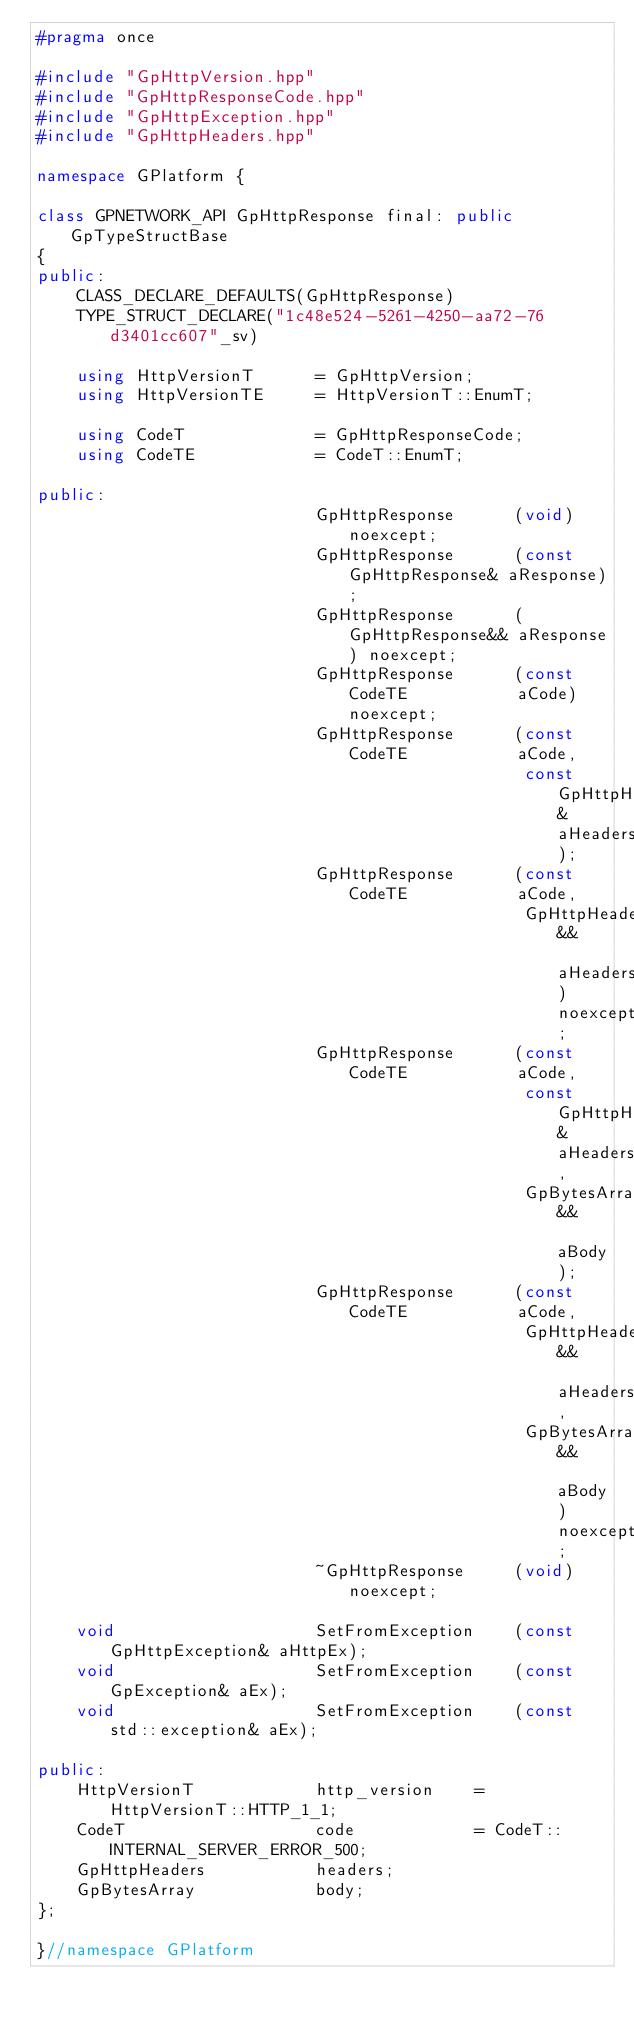Convert code to text. <code><loc_0><loc_0><loc_500><loc_500><_C++_>#pragma once

#include "GpHttpVersion.hpp"
#include "GpHttpResponseCode.hpp"
#include "GpHttpException.hpp"
#include "GpHttpHeaders.hpp"

namespace GPlatform {

class GPNETWORK_API GpHttpResponse final: public GpTypeStructBase
{
public:
    CLASS_DECLARE_DEFAULTS(GpHttpResponse)
    TYPE_STRUCT_DECLARE("1c48e524-5261-4250-aa72-76d3401cc607"_sv)

    using HttpVersionT      = GpHttpVersion;
    using HttpVersionTE     = HttpVersionT::EnumT;

    using CodeT             = GpHttpResponseCode;
    using CodeTE            = CodeT::EnumT;

public:
                            GpHttpResponse      (void) noexcept;
                            GpHttpResponse      (const GpHttpResponse& aResponse);
                            GpHttpResponse      (GpHttpResponse&& aResponse) noexcept;
                            GpHttpResponse      (const CodeTE           aCode) noexcept;
                            GpHttpResponse      (const CodeTE           aCode,
                                                 const GpHttpHeaders&   aHeaders);
                            GpHttpResponse      (const CodeTE           aCode,
                                                 GpHttpHeaders&&        aHeaders) noexcept;
                            GpHttpResponse      (const CodeTE           aCode,
                                                 const GpHttpHeaders&   aHeaders,
                                                 GpBytesArray&&         aBody);
                            GpHttpResponse      (const CodeTE           aCode,
                                                 GpHttpHeaders&&        aHeaders,
                                                 GpBytesArray&&         aBody) noexcept;
                            ~GpHttpResponse     (void) noexcept;

    void                    SetFromException    (const GpHttpException& aHttpEx);
    void                    SetFromException    (const GpException& aEx);
    void                    SetFromException    (const std::exception& aEx);

public:
    HttpVersionT            http_version    = HttpVersionT::HTTP_1_1;
    CodeT                   code            = CodeT::INTERNAL_SERVER_ERROR_500;
    GpHttpHeaders           headers;
    GpBytesArray            body;
};

}//namespace GPlatform
</code> 